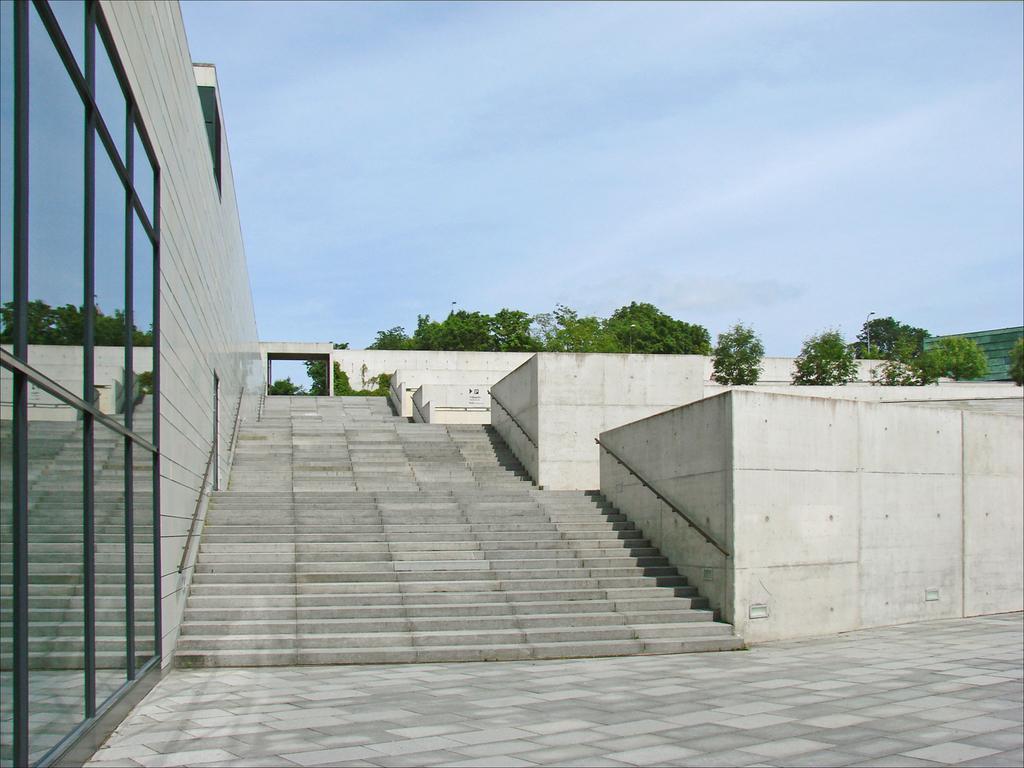Describe this image in one or two sentences. In this picture we can observe steps. On the left side we can observe a wall and mirrors. In the background there are trees and a sky. 